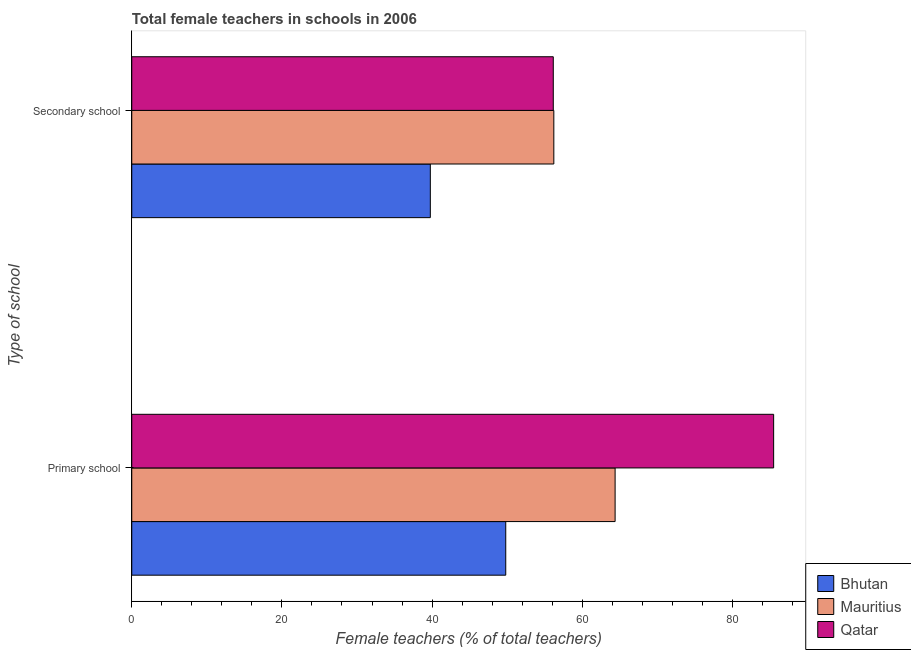How many bars are there on the 2nd tick from the bottom?
Give a very brief answer. 3. What is the label of the 1st group of bars from the top?
Ensure brevity in your answer.  Secondary school. What is the percentage of female teachers in secondary schools in Mauritius?
Give a very brief answer. 56.22. Across all countries, what is the maximum percentage of female teachers in secondary schools?
Provide a short and direct response. 56.22. Across all countries, what is the minimum percentage of female teachers in secondary schools?
Offer a terse response. 39.77. In which country was the percentage of female teachers in primary schools maximum?
Offer a terse response. Qatar. In which country was the percentage of female teachers in primary schools minimum?
Provide a succinct answer. Bhutan. What is the total percentage of female teachers in primary schools in the graph?
Offer a very short reply. 199.69. What is the difference between the percentage of female teachers in primary schools in Qatar and that in Mauritius?
Your response must be concise. 21.11. What is the difference between the percentage of female teachers in secondary schools in Qatar and the percentage of female teachers in primary schools in Bhutan?
Offer a very short reply. 6.33. What is the average percentage of female teachers in secondary schools per country?
Make the answer very short. 50.71. What is the difference between the percentage of female teachers in primary schools and percentage of female teachers in secondary schools in Bhutan?
Your answer should be very brief. 10.05. What is the ratio of the percentage of female teachers in secondary schools in Bhutan to that in Mauritius?
Ensure brevity in your answer.  0.71. Is the percentage of female teachers in primary schools in Bhutan less than that in Qatar?
Ensure brevity in your answer.  Yes. In how many countries, is the percentage of female teachers in primary schools greater than the average percentage of female teachers in primary schools taken over all countries?
Ensure brevity in your answer.  1. What does the 1st bar from the top in Secondary school represents?
Make the answer very short. Qatar. What does the 3rd bar from the bottom in Secondary school represents?
Your response must be concise. Qatar. Are all the bars in the graph horizontal?
Offer a very short reply. Yes. How many countries are there in the graph?
Your answer should be compact. 3. What is the difference between two consecutive major ticks on the X-axis?
Your response must be concise. 20. Are the values on the major ticks of X-axis written in scientific E-notation?
Your answer should be compact. No. Does the graph contain grids?
Keep it short and to the point. No. What is the title of the graph?
Offer a very short reply. Total female teachers in schools in 2006. Does "Belgium" appear as one of the legend labels in the graph?
Offer a very short reply. No. What is the label or title of the X-axis?
Keep it short and to the point. Female teachers (% of total teachers). What is the label or title of the Y-axis?
Offer a terse response. Type of school. What is the Female teachers (% of total teachers) of Bhutan in Primary school?
Provide a short and direct response. 49.81. What is the Female teachers (% of total teachers) in Mauritius in Primary school?
Provide a short and direct response. 64.38. What is the Female teachers (% of total teachers) in Qatar in Primary school?
Keep it short and to the point. 85.49. What is the Female teachers (% of total teachers) of Bhutan in Secondary school?
Your response must be concise. 39.77. What is the Female teachers (% of total teachers) in Mauritius in Secondary school?
Your answer should be compact. 56.22. What is the Female teachers (% of total teachers) of Qatar in Secondary school?
Keep it short and to the point. 56.15. Across all Type of school, what is the maximum Female teachers (% of total teachers) of Bhutan?
Your response must be concise. 49.81. Across all Type of school, what is the maximum Female teachers (% of total teachers) of Mauritius?
Ensure brevity in your answer.  64.38. Across all Type of school, what is the maximum Female teachers (% of total teachers) in Qatar?
Your answer should be compact. 85.49. Across all Type of school, what is the minimum Female teachers (% of total teachers) of Bhutan?
Provide a succinct answer. 39.77. Across all Type of school, what is the minimum Female teachers (% of total teachers) in Mauritius?
Your response must be concise. 56.22. Across all Type of school, what is the minimum Female teachers (% of total teachers) of Qatar?
Make the answer very short. 56.15. What is the total Female teachers (% of total teachers) in Bhutan in the graph?
Make the answer very short. 89.58. What is the total Female teachers (% of total teachers) of Mauritius in the graph?
Your answer should be very brief. 120.6. What is the total Female teachers (% of total teachers) of Qatar in the graph?
Make the answer very short. 141.64. What is the difference between the Female teachers (% of total teachers) in Bhutan in Primary school and that in Secondary school?
Provide a succinct answer. 10.05. What is the difference between the Female teachers (% of total teachers) of Mauritius in Primary school and that in Secondary school?
Offer a very short reply. 8.16. What is the difference between the Female teachers (% of total teachers) in Qatar in Primary school and that in Secondary school?
Provide a short and direct response. 29.35. What is the difference between the Female teachers (% of total teachers) of Bhutan in Primary school and the Female teachers (% of total teachers) of Mauritius in Secondary school?
Offer a terse response. -6.4. What is the difference between the Female teachers (% of total teachers) in Bhutan in Primary school and the Female teachers (% of total teachers) in Qatar in Secondary school?
Provide a short and direct response. -6.33. What is the difference between the Female teachers (% of total teachers) of Mauritius in Primary school and the Female teachers (% of total teachers) of Qatar in Secondary school?
Offer a terse response. 8.23. What is the average Female teachers (% of total teachers) of Bhutan per Type of school?
Provide a succinct answer. 44.79. What is the average Female teachers (% of total teachers) in Mauritius per Type of school?
Provide a short and direct response. 60.3. What is the average Female teachers (% of total teachers) of Qatar per Type of school?
Your answer should be compact. 70.82. What is the difference between the Female teachers (% of total teachers) in Bhutan and Female teachers (% of total teachers) in Mauritius in Primary school?
Keep it short and to the point. -14.57. What is the difference between the Female teachers (% of total teachers) in Bhutan and Female teachers (% of total teachers) in Qatar in Primary school?
Ensure brevity in your answer.  -35.68. What is the difference between the Female teachers (% of total teachers) in Mauritius and Female teachers (% of total teachers) in Qatar in Primary school?
Keep it short and to the point. -21.11. What is the difference between the Female teachers (% of total teachers) in Bhutan and Female teachers (% of total teachers) in Mauritius in Secondary school?
Provide a succinct answer. -16.45. What is the difference between the Female teachers (% of total teachers) in Bhutan and Female teachers (% of total teachers) in Qatar in Secondary school?
Offer a terse response. -16.38. What is the difference between the Female teachers (% of total teachers) of Mauritius and Female teachers (% of total teachers) of Qatar in Secondary school?
Your answer should be compact. 0.07. What is the ratio of the Female teachers (% of total teachers) in Bhutan in Primary school to that in Secondary school?
Keep it short and to the point. 1.25. What is the ratio of the Female teachers (% of total teachers) of Mauritius in Primary school to that in Secondary school?
Keep it short and to the point. 1.15. What is the ratio of the Female teachers (% of total teachers) in Qatar in Primary school to that in Secondary school?
Ensure brevity in your answer.  1.52. What is the difference between the highest and the second highest Female teachers (% of total teachers) in Bhutan?
Provide a short and direct response. 10.05. What is the difference between the highest and the second highest Female teachers (% of total teachers) of Mauritius?
Provide a short and direct response. 8.16. What is the difference between the highest and the second highest Female teachers (% of total teachers) of Qatar?
Your response must be concise. 29.35. What is the difference between the highest and the lowest Female teachers (% of total teachers) of Bhutan?
Offer a very short reply. 10.05. What is the difference between the highest and the lowest Female teachers (% of total teachers) in Mauritius?
Provide a succinct answer. 8.16. What is the difference between the highest and the lowest Female teachers (% of total teachers) of Qatar?
Your answer should be very brief. 29.35. 